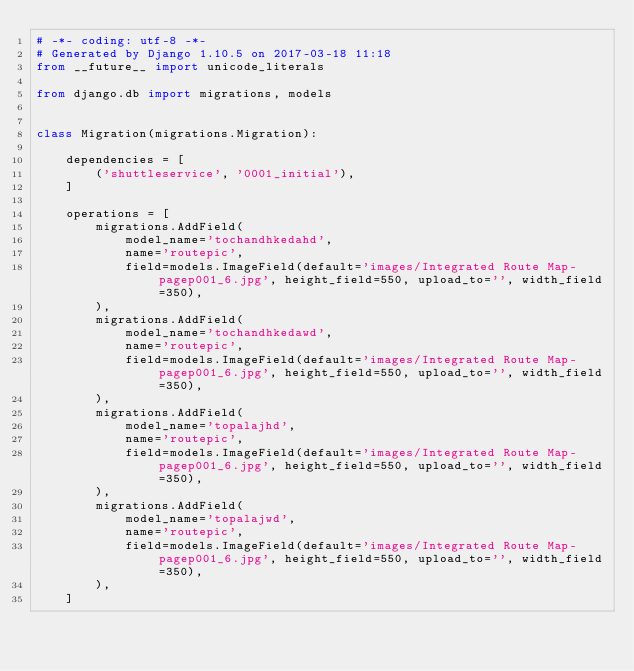Convert code to text. <code><loc_0><loc_0><loc_500><loc_500><_Python_># -*- coding: utf-8 -*-
# Generated by Django 1.10.5 on 2017-03-18 11:18
from __future__ import unicode_literals

from django.db import migrations, models


class Migration(migrations.Migration):

    dependencies = [
        ('shuttleservice', '0001_initial'),
    ]

    operations = [
        migrations.AddField(
            model_name='tochandhkedahd',
            name='routepic',
            field=models.ImageField(default='images/Integrated Route Map-pagep001_6.jpg', height_field=550, upload_to='', width_field=350),
        ),
        migrations.AddField(
            model_name='tochandhkedawd',
            name='routepic',
            field=models.ImageField(default='images/Integrated Route Map-pagep001_6.jpg', height_field=550, upload_to='', width_field=350),
        ),
        migrations.AddField(
            model_name='topalajhd',
            name='routepic',
            field=models.ImageField(default='images/Integrated Route Map-pagep001_6.jpg', height_field=550, upload_to='', width_field=350),
        ),
        migrations.AddField(
            model_name='topalajwd',
            name='routepic',
            field=models.ImageField(default='images/Integrated Route Map-pagep001_6.jpg', height_field=550, upload_to='', width_field=350),
        ),
    ]
</code> 